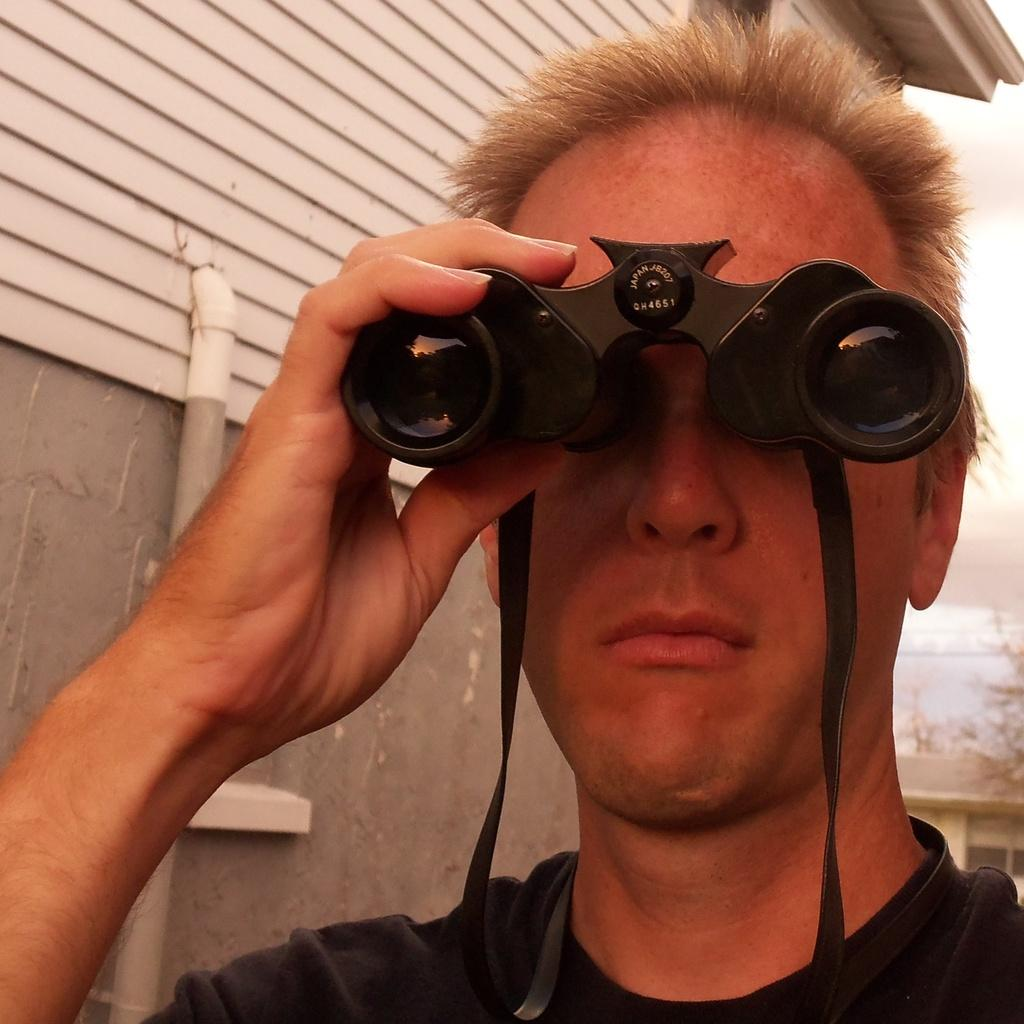What is the person in the image holding? The person in the image is holding binoculars. What can be seen in the background of the image? There is a wall in the background of the image. What is attached to the wall in the image? There is a pipe on the wall in the image. What type of cabbage can be seen growing on the wall in the image? There is no cabbage present in the image; it features a person holding binoculars with a wall and a pipe in the background. What town is visible in the background of the image? The image does not depict a town; it shows a person holding binoculars with a wall and a pipe in the background. 